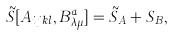Convert formula to latex. <formula><loc_0><loc_0><loc_500><loc_500>\tilde { S } [ A _ { i j k l } , B ^ { a } _ { \lambda \mu } ] = \tilde { S } _ { A } + S _ { B } ,</formula> 